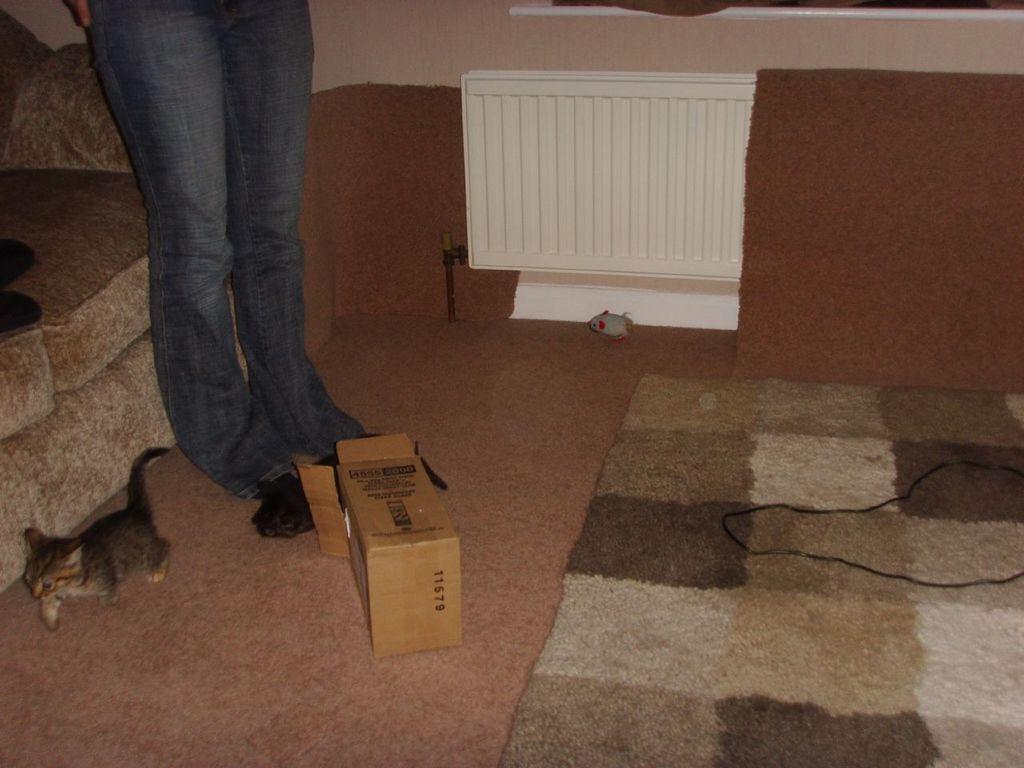Could you give a brief overview of what you see in this image? This picture is clicked inside the room. On the left we can see a person wearing trousers and standing on the ground and we can see a kitten seems to be walking, we can see the floor mat, cable, box, couch and some other objects. In the background we can see the wall. 